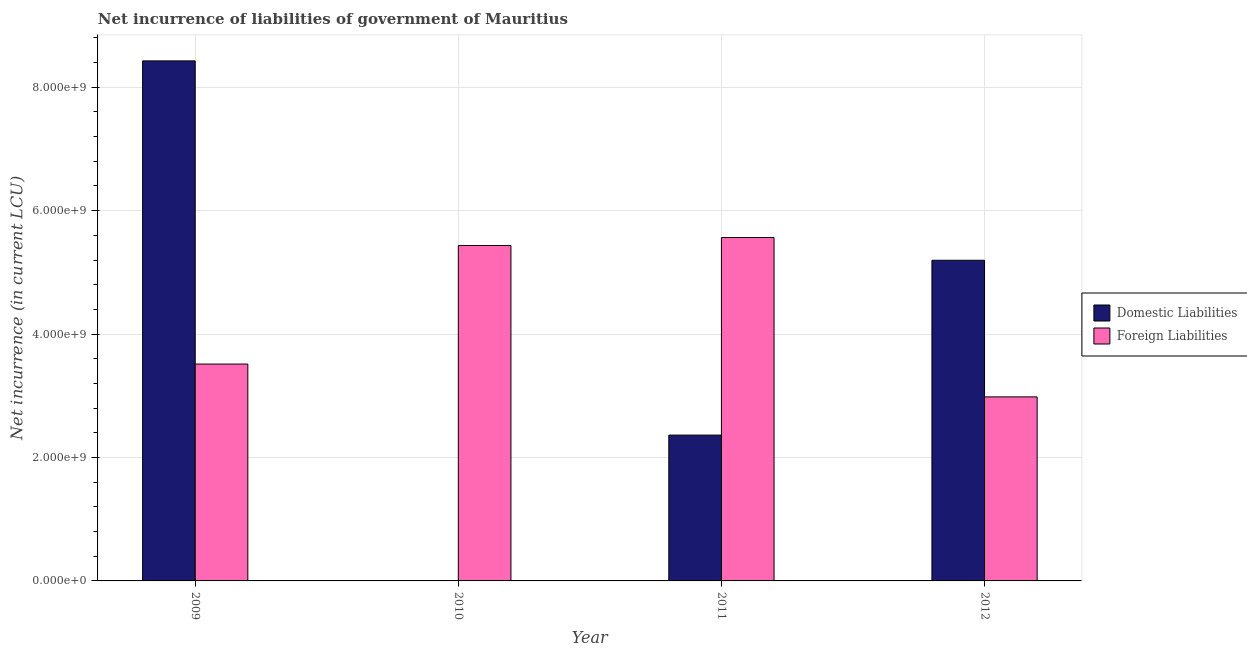How many bars are there on the 3rd tick from the left?
Your answer should be compact. 2. How many bars are there on the 4th tick from the right?
Ensure brevity in your answer.  2. In how many cases, is the number of bars for a given year not equal to the number of legend labels?
Keep it short and to the point. 1. What is the net incurrence of foreign liabilities in 2011?
Ensure brevity in your answer.  5.56e+09. Across all years, what is the maximum net incurrence of domestic liabilities?
Offer a terse response. 8.43e+09. What is the total net incurrence of domestic liabilities in the graph?
Offer a terse response. 1.60e+1. What is the difference between the net incurrence of foreign liabilities in 2010 and that in 2011?
Ensure brevity in your answer.  -1.28e+08. What is the difference between the net incurrence of foreign liabilities in 2012 and the net incurrence of domestic liabilities in 2011?
Your answer should be very brief. -2.58e+09. What is the average net incurrence of domestic liabilities per year?
Keep it short and to the point. 4.00e+09. What is the ratio of the net incurrence of foreign liabilities in 2010 to that in 2012?
Your answer should be compact. 1.82. Is the difference between the net incurrence of foreign liabilities in 2011 and 2012 greater than the difference between the net incurrence of domestic liabilities in 2011 and 2012?
Provide a succinct answer. No. What is the difference between the highest and the second highest net incurrence of foreign liabilities?
Offer a very short reply. 1.28e+08. What is the difference between the highest and the lowest net incurrence of foreign liabilities?
Your answer should be compact. 2.58e+09. How many bars are there?
Your answer should be very brief. 7. Are the values on the major ticks of Y-axis written in scientific E-notation?
Give a very brief answer. Yes. Does the graph contain any zero values?
Make the answer very short. Yes. Does the graph contain grids?
Offer a terse response. Yes. Where does the legend appear in the graph?
Your response must be concise. Center right. How are the legend labels stacked?
Give a very brief answer. Vertical. What is the title of the graph?
Ensure brevity in your answer.  Net incurrence of liabilities of government of Mauritius. What is the label or title of the X-axis?
Provide a succinct answer. Year. What is the label or title of the Y-axis?
Keep it short and to the point. Net incurrence (in current LCU). What is the Net incurrence (in current LCU) in Domestic Liabilities in 2009?
Provide a succinct answer. 8.43e+09. What is the Net incurrence (in current LCU) in Foreign Liabilities in 2009?
Provide a short and direct response. 3.51e+09. What is the Net incurrence (in current LCU) in Domestic Liabilities in 2010?
Keep it short and to the point. 0. What is the Net incurrence (in current LCU) in Foreign Liabilities in 2010?
Offer a very short reply. 5.44e+09. What is the Net incurrence (in current LCU) in Domestic Liabilities in 2011?
Your response must be concise. 2.36e+09. What is the Net incurrence (in current LCU) of Foreign Liabilities in 2011?
Offer a very short reply. 5.56e+09. What is the Net incurrence (in current LCU) of Domestic Liabilities in 2012?
Your answer should be compact. 5.20e+09. What is the Net incurrence (in current LCU) in Foreign Liabilities in 2012?
Provide a succinct answer. 2.98e+09. Across all years, what is the maximum Net incurrence (in current LCU) of Domestic Liabilities?
Provide a succinct answer. 8.43e+09. Across all years, what is the maximum Net incurrence (in current LCU) in Foreign Liabilities?
Offer a terse response. 5.56e+09. Across all years, what is the minimum Net incurrence (in current LCU) in Foreign Liabilities?
Provide a succinct answer. 2.98e+09. What is the total Net incurrence (in current LCU) in Domestic Liabilities in the graph?
Your answer should be compact. 1.60e+1. What is the total Net incurrence (in current LCU) of Foreign Liabilities in the graph?
Your response must be concise. 1.75e+1. What is the difference between the Net incurrence (in current LCU) of Foreign Liabilities in 2009 and that in 2010?
Give a very brief answer. -1.92e+09. What is the difference between the Net incurrence (in current LCU) of Domestic Liabilities in 2009 and that in 2011?
Offer a terse response. 6.06e+09. What is the difference between the Net incurrence (in current LCU) in Foreign Liabilities in 2009 and that in 2011?
Your answer should be very brief. -2.05e+09. What is the difference between the Net incurrence (in current LCU) of Domestic Liabilities in 2009 and that in 2012?
Provide a short and direct response. 3.23e+09. What is the difference between the Net incurrence (in current LCU) in Foreign Liabilities in 2009 and that in 2012?
Keep it short and to the point. 5.32e+08. What is the difference between the Net incurrence (in current LCU) in Foreign Liabilities in 2010 and that in 2011?
Your answer should be compact. -1.28e+08. What is the difference between the Net incurrence (in current LCU) in Foreign Liabilities in 2010 and that in 2012?
Provide a short and direct response. 2.45e+09. What is the difference between the Net incurrence (in current LCU) of Domestic Liabilities in 2011 and that in 2012?
Provide a succinct answer. -2.83e+09. What is the difference between the Net incurrence (in current LCU) of Foreign Liabilities in 2011 and that in 2012?
Make the answer very short. 2.58e+09. What is the difference between the Net incurrence (in current LCU) in Domestic Liabilities in 2009 and the Net incurrence (in current LCU) in Foreign Liabilities in 2010?
Your response must be concise. 2.99e+09. What is the difference between the Net incurrence (in current LCU) of Domestic Liabilities in 2009 and the Net incurrence (in current LCU) of Foreign Liabilities in 2011?
Give a very brief answer. 2.86e+09. What is the difference between the Net incurrence (in current LCU) of Domestic Liabilities in 2009 and the Net incurrence (in current LCU) of Foreign Liabilities in 2012?
Offer a very short reply. 5.45e+09. What is the difference between the Net incurrence (in current LCU) in Domestic Liabilities in 2011 and the Net incurrence (in current LCU) in Foreign Liabilities in 2012?
Your response must be concise. -6.19e+08. What is the average Net incurrence (in current LCU) in Domestic Liabilities per year?
Provide a succinct answer. 4.00e+09. What is the average Net incurrence (in current LCU) of Foreign Liabilities per year?
Your response must be concise. 4.37e+09. In the year 2009, what is the difference between the Net incurrence (in current LCU) in Domestic Liabilities and Net incurrence (in current LCU) in Foreign Liabilities?
Make the answer very short. 4.91e+09. In the year 2011, what is the difference between the Net incurrence (in current LCU) of Domestic Liabilities and Net incurrence (in current LCU) of Foreign Liabilities?
Your answer should be compact. -3.20e+09. In the year 2012, what is the difference between the Net incurrence (in current LCU) in Domestic Liabilities and Net incurrence (in current LCU) in Foreign Liabilities?
Provide a short and direct response. 2.21e+09. What is the ratio of the Net incurrence (in current LCU) in Foreign Liabilities in 2009 to that in 2010?
Make the answer very short. 0.65. What is the ratio of the Net incurrence (in current LCU) in Domestic Liabilities in 2009 to that in 2011?
Ensure brevity in your answer.  3.57. What is the ratio of the Net incurrence (in current LCU) in Foreign Liabilities in 2009 to that in 2011?
Ensure brevity in your answer.  0.63. What is the ratio of the Net incurrence (in current LCU) in Domestic Liabilities in 2009 to that in 2012?
Ensure brevity in your answer.  1.62. What is the ratio of the Net incurrence (in current LCU) of Foreign Liabilities in 2009 to that in 2012?
Your response must be concise. 1.18. What is the ratio of the Net incurrence (in current LCU) in Foreign Liabilities in 2010 to that in 2011?
Offer a very short reply. 0.98. What is the ratio of the Net incurrence (in current LCU) in Foreign Liabilities in 2010 to that in 2012?
Make the answer very short. 1.82. What is the ratio of the Net incurrence (in current LCU) of Domestic Liabilities in 2011 to that in 2012?
Offer a terse response. 0.45. What is the ratio of the Net incurrence (in current LCU) in Foreign Liabilities in 2011 to that in 2012?
Offer a very short reply. 1.87. What is the difference between the highest and the second highest Net incurrence (in current LCU) in Domestic Liabilities?
Provide a succinct answer. 3.23e+09. What is the difference between the highest and the second highest Net incurrence (in current LCU) in Foreign Liabilities?
Offer a very short reply. 1.28e+08. What is the difference between the highest and the lowest Net incurrence (in current LCU) in Domestic Liabilities?
Provide a succinct answer. 8.43e+09. What is the difference between the highest and the lowest Net incurrence (in current LCU) in Foreign Liabilities?
Make the answer very short. 2.58e+09. 